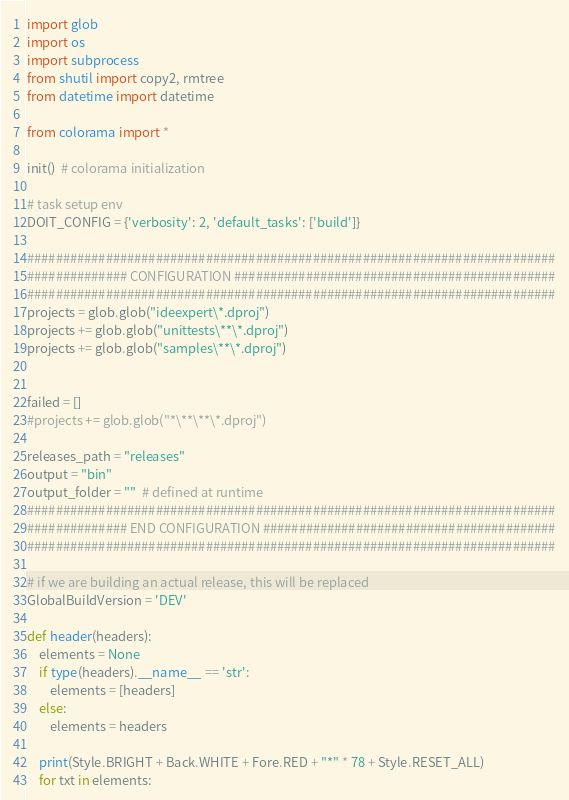Convert code to text. <code><loc_0><loc_0><loc_500><loc_500><_Python_>import glob
import os
import subprocess
from shutil import copy2, rmtree
from datetime import datetime

from colorama import *

init()  # colorama initialization

# task setup env
DOIT_CONFIG = {'verbosity': 2, 'default_tasks': ['build']}

##########################################################################
############## CONFIGURATION #############################################
##########################################################################
projects = glob.glob("ideexpert\*.dproj")
projects += glob.glob("unittests\**\*.dproj")
projects += glob.glob("samples\**\*.dproj")


failed = []
#projects += glob.glob("*\**\**\*.dproj")

releases_path = "releases"
output = "bin"
output_folder = ""  # defined at runtime
##########################################################################
############## END CONFIGURATION #########################################
##########################################################################

# if we are building an actual release, this will be replaced
GlobalBuildVersion = 'DEV'

def header(headers):
    elements = None
    if type(headers).__name__ == 'str':
        elements = [headers]
    else:
        elements = headers

    print(Style.BRIGHT + Back.WHITE + Fore.RED + "*" * 78 + Style.RESET_ALL)
    for txt in elements:</code> 